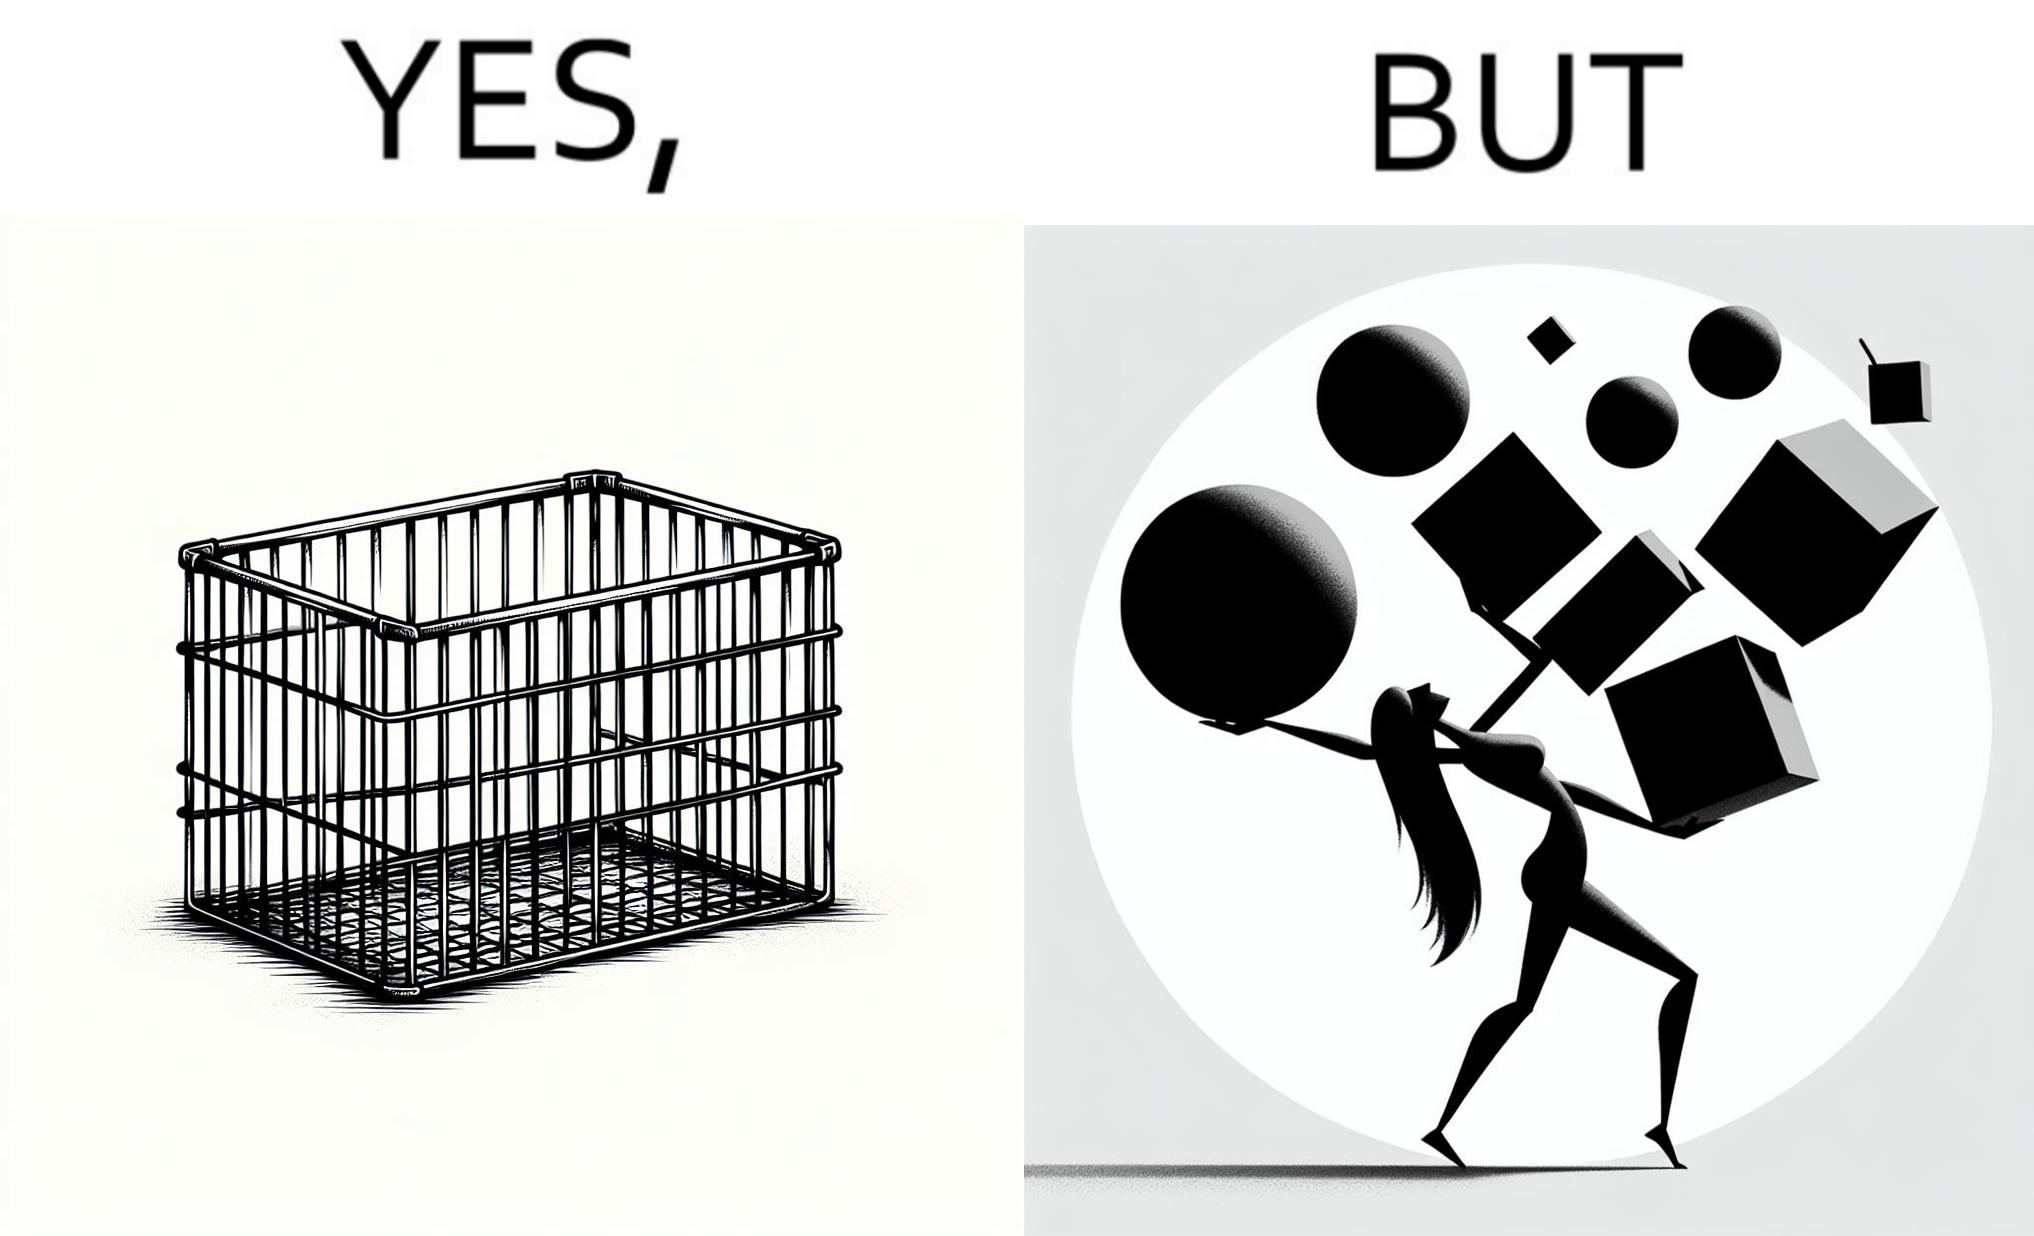Describe what you see in the left and right parts of this image. In the left part of the image: a steel frame basket In the right part of the image: a woman carrying many objects at once trying to hold them, and protecting them from falling off 